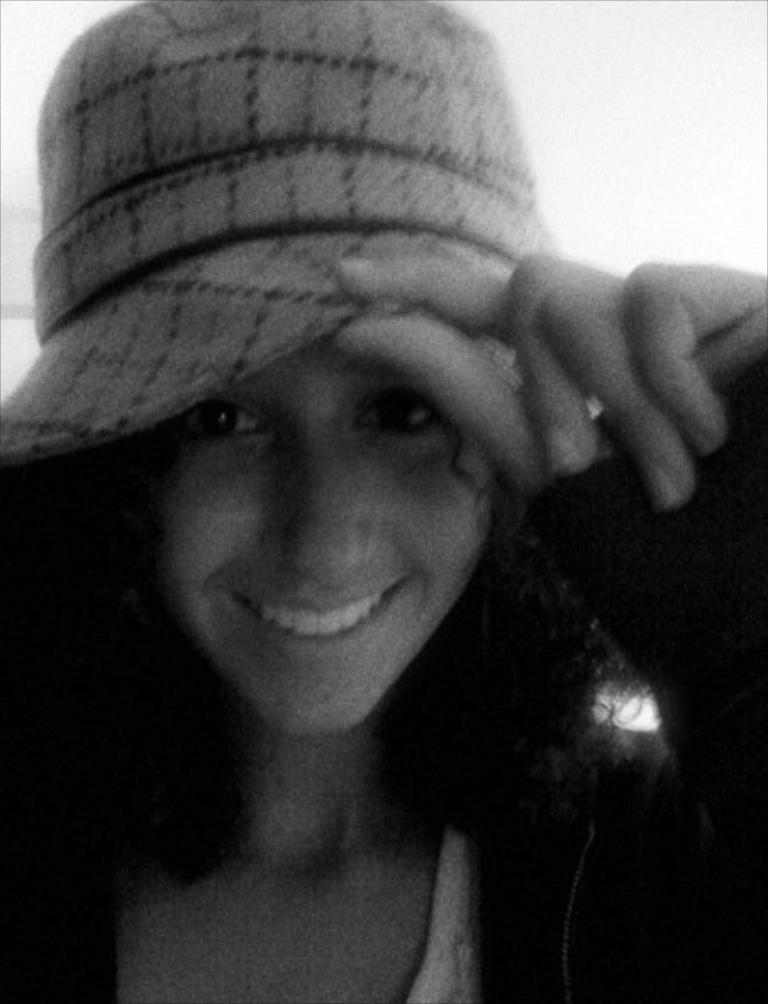What is the color scheme of the image? The image is black and white. Who is the main subject in the image? There is a girl in the center of the image. What is the girl wearing on her head? The girl is wearing a cap. Where is the toothpaste located in the image? There is no toothpaste present in the image. What type of badge is the girl wearing in the image? There is no badge visible in the image; the girl is only wearing a cap. 